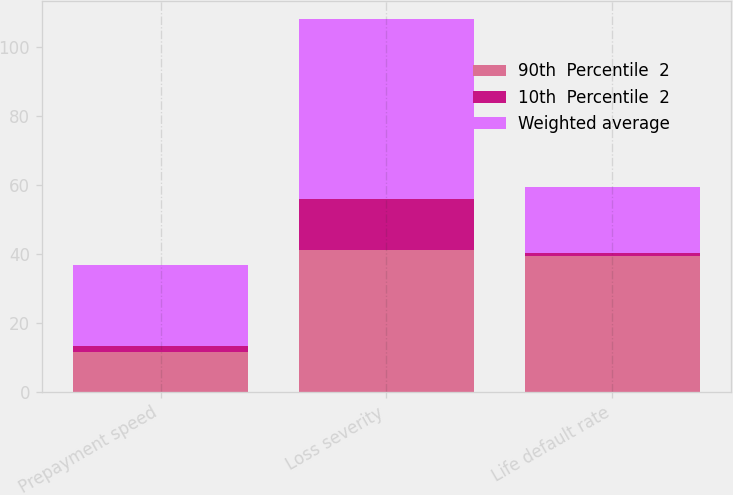Convert chart to OTSL. <chart><loc_0><loc_0><loc_500><loc_500><stacked_bar_chart><ecel><fcel>Prepayment speed<fcel>Loss severity<fcel>Life default rate<nl><fcel>90th  Percentile  2<fcel>11.6<fcel>41.3<fcel>39.4<nl><fcel>10th  Percentile  2<fcel>1.8<fcel>14.7<fcel>0.9<nl><fcel>Weighted average<fcel>23.6<fcel>52.1<fcel>19.15<nl></chart> 